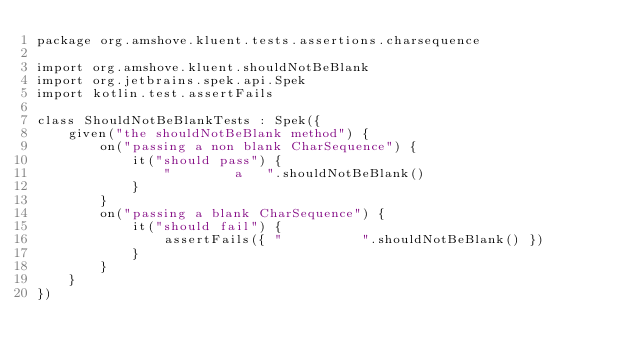Convert code to text. <code><loc_0><loc_0><loc_500><loc_500><_Kotlin_>package org.amshove.kluent.tests.assertions.charsequence

import org.amshove.kluent.shouldNotBeBlank
import org.jetbrains.spek.api.Spek
import kotlin.test.assertFails

class ShouldNotBeBlankTests : Spek({
    given("the shouldNotBeBlank method") {
        on("passing a non blank CharSequence") {
            it("should pass") {
                "        a   ".shouldNotBeBlank()
            }
        }
        on("passing a blank CharSequence") {
            it("should fail") {
                assertFails({ "          ".shouldNotBeBlank() })
            }
        }
    }
})
</code> 